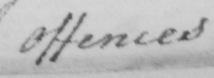Can you read and transcribe this handwriting? Offences 